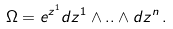<formula> <loc_0><loc_0><loc_500><loc_500>\Omega = e ^ { z ^ { 1 } } d z ^ { 1 } \wedge . . \wedge d z ^ { n } \, .</formula> 